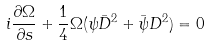Convert formula to latex. <formula><loc_0><loc_0><loc_500><loc_500>i \frac { \partial \Omega } { \partial s } + \frac { 1 } { 4 } \Omega ( \psi \bar { D } ^ { 2 } + \bar { \psi } D ^ { 2 } ) = 0</formula> 